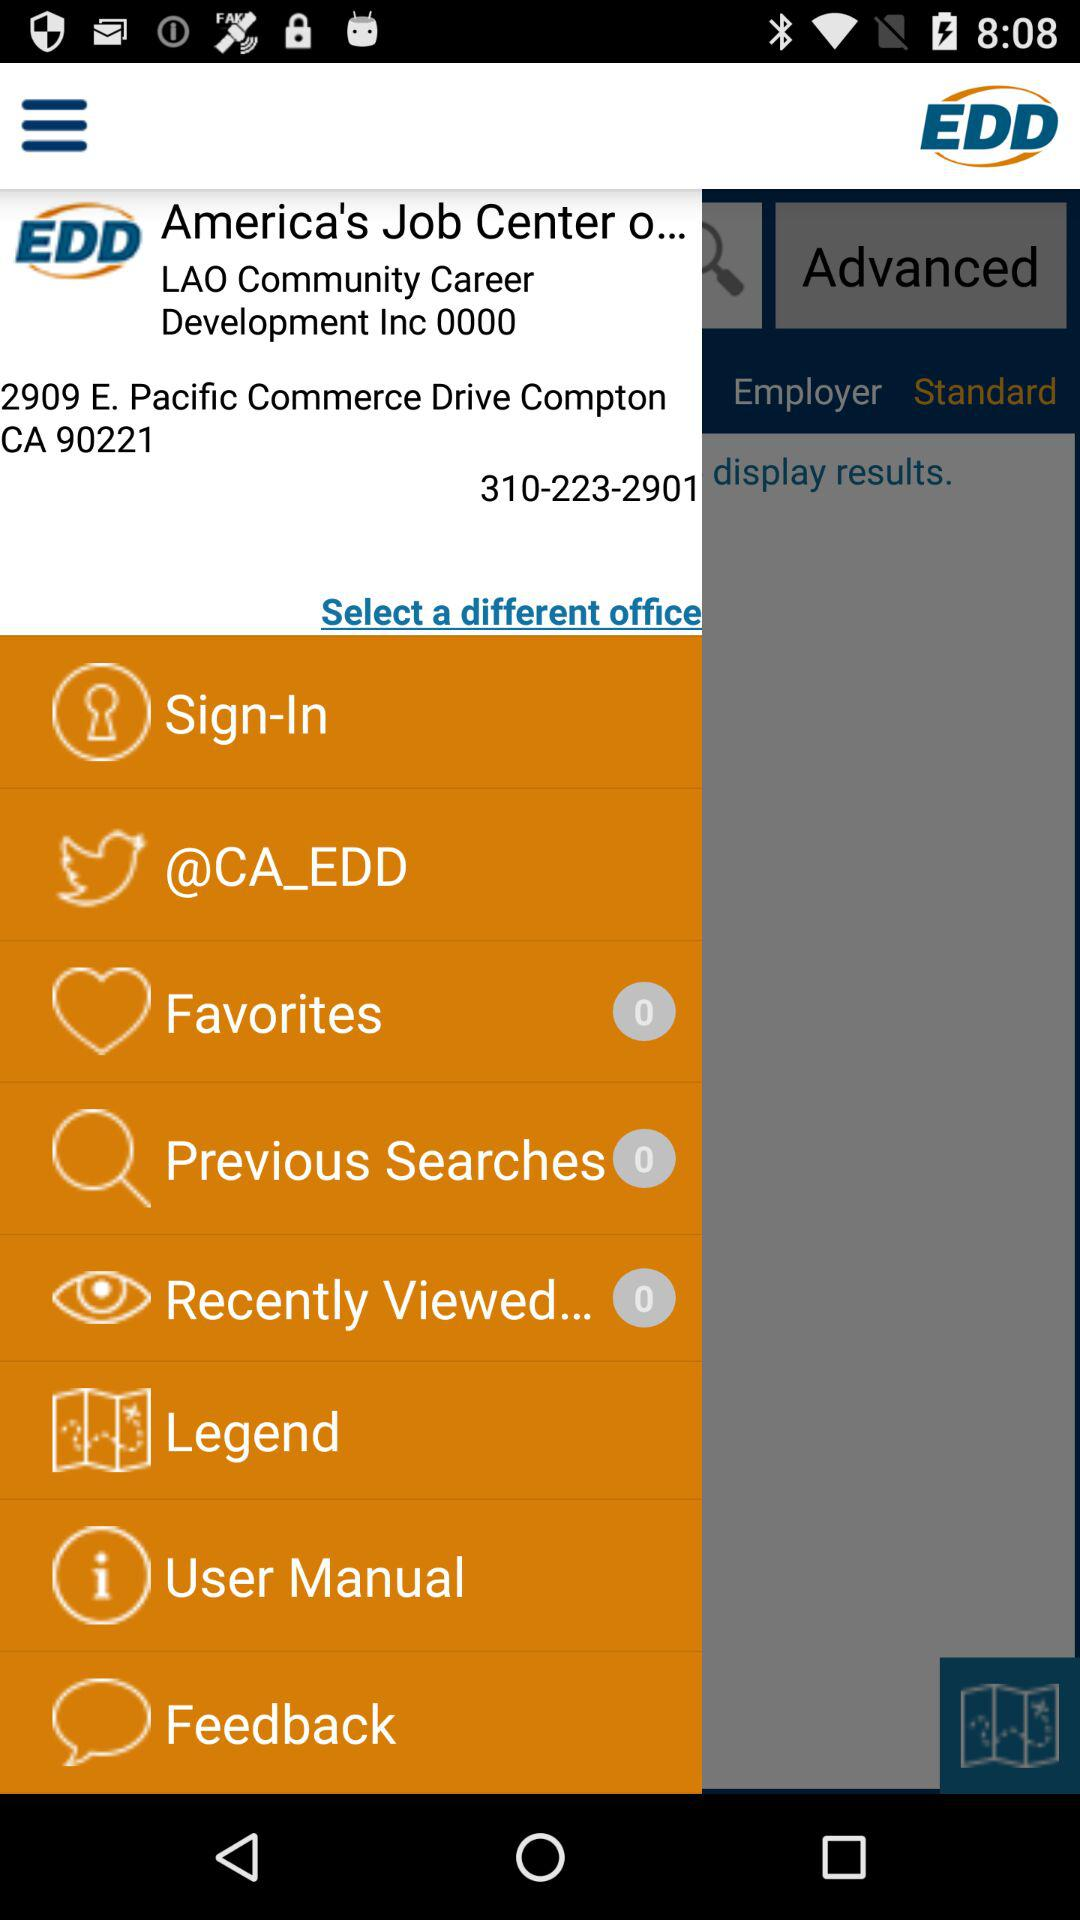What is the name of the application? The name of the application is "EDD". 